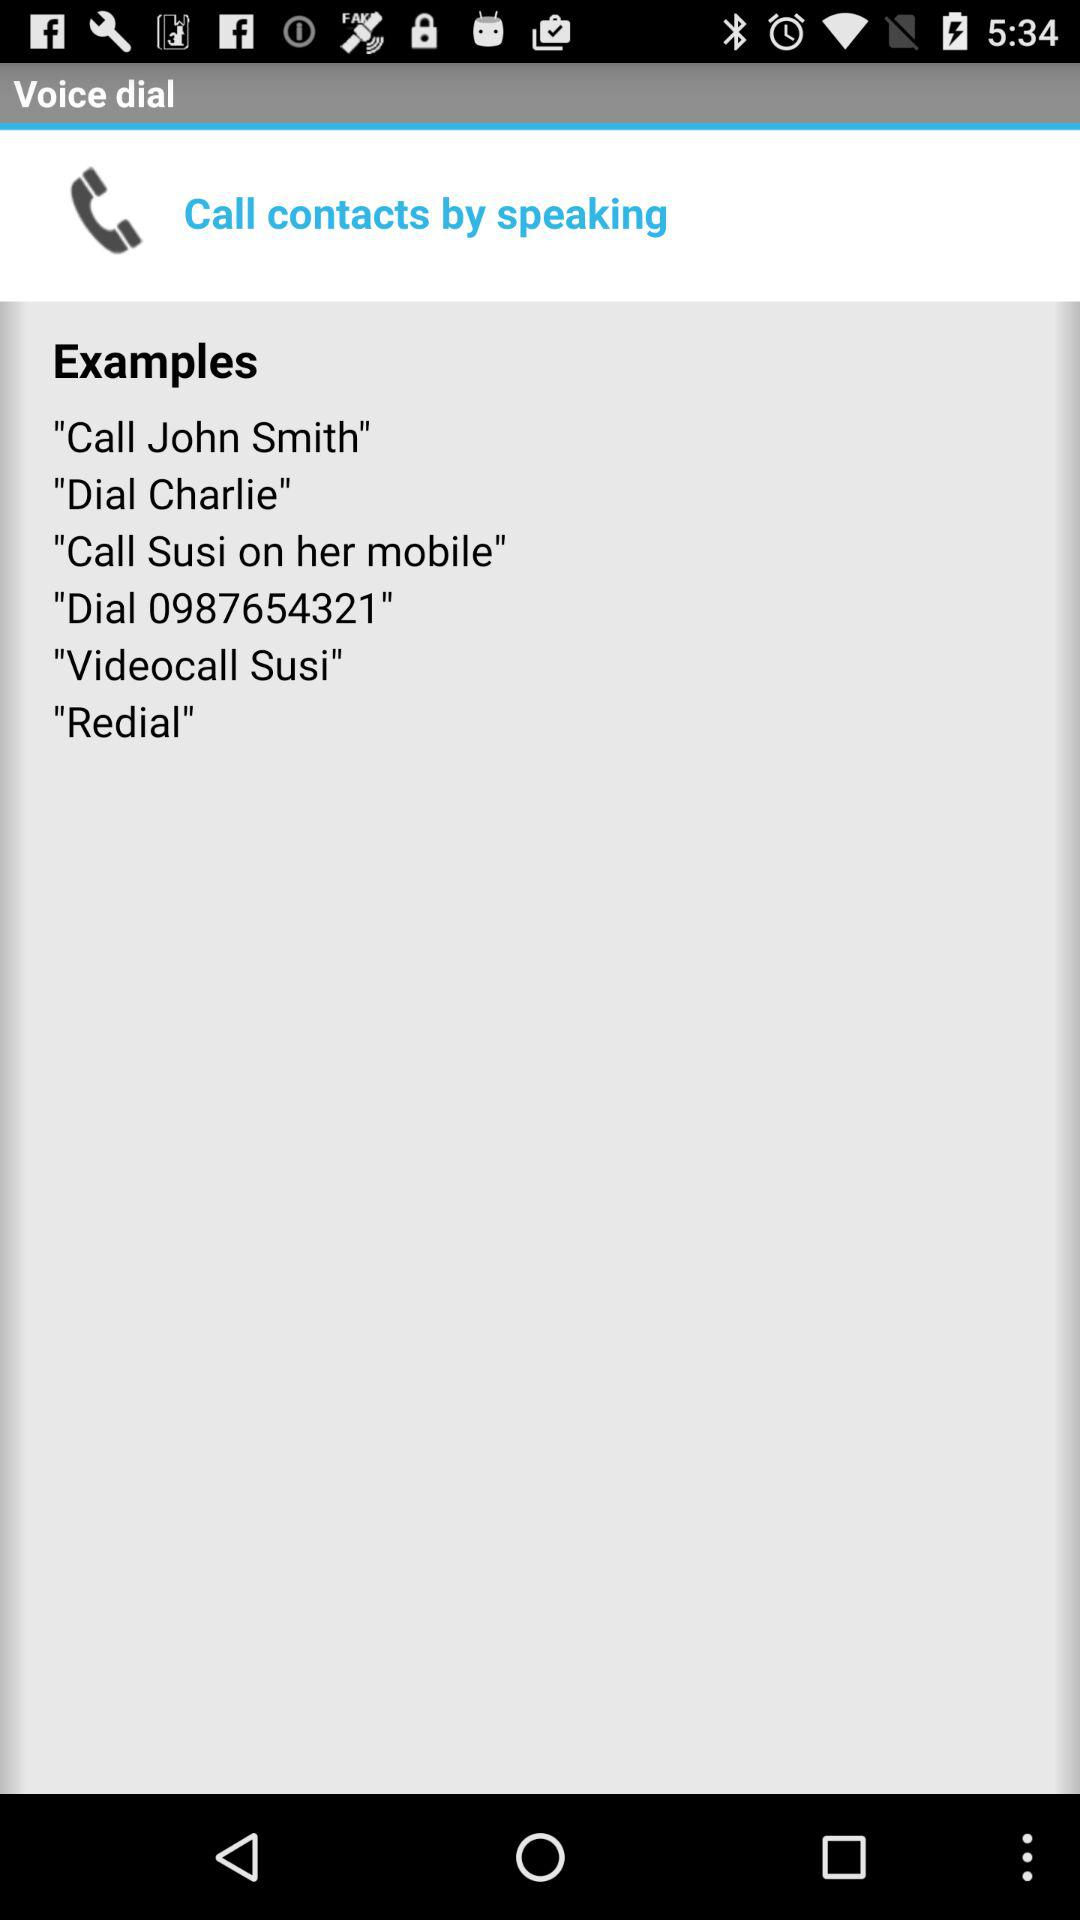How do I call contacts? You can call contacts by speaking. 